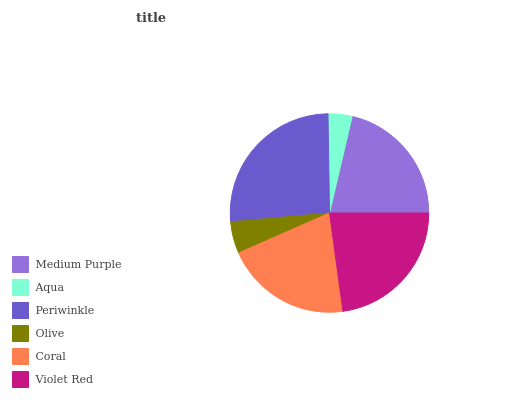Is Aqua the minimum?
Answer yes or no. Yes. Is Periwinkle the maximum?
Answer yes or no. Yes. Is Periwinkle the minimum?
Answer yes or no. No. Is Aqua the maximum?
Answer yes or no. No. Is Periwinkle greater than Aqua?
Answer yes or no. Yes. Is Aqua less than Periwinkle?
Answer yes or no. Yes. Is Aqua greater than Periwinkle?
Answer yes or no. No. Is Periwinkle less than Aqua?
Answer yes or no. No. Is Medium Purple the high median?
Answer yes or no. Yes. Is Coral the low median?
Answer yes or no. Yes. Is Violet Red the high median?
Answer yes or no. No. Is Violet Red the low median?
Answer yes or no. No. 